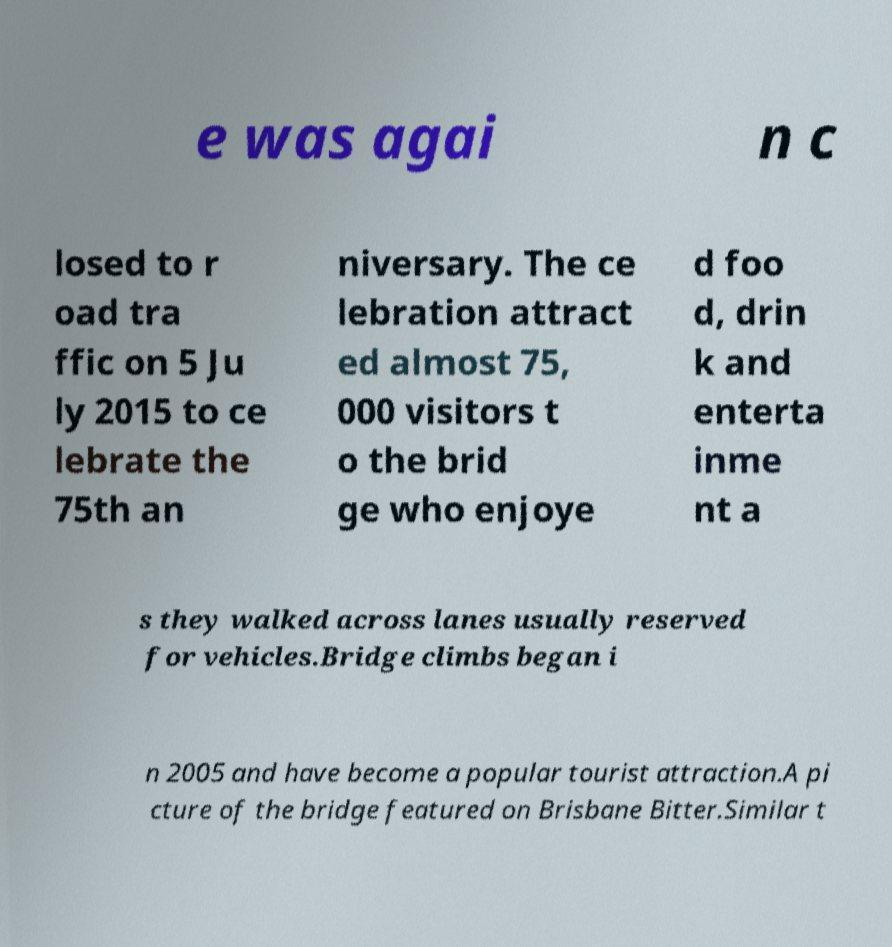What messages or text are displayed in this image? I need them in a readable, typed format. e was agai n c losed to r oad tra ffic on 5 Ju ly 2015 to ce lebrate the 75th an niversary. The ce lebration attract ed almost 75, 000 visitors t o the brid ge who enjoye d foo d, drin k and enterta inme nt a s they walked across lanes usually reserved for vehicles.Bridge climbs began i n 2005 and have become a popular tourist attraction.A pi cture of the bridge featured on Brisbane Bitter.Similar t 